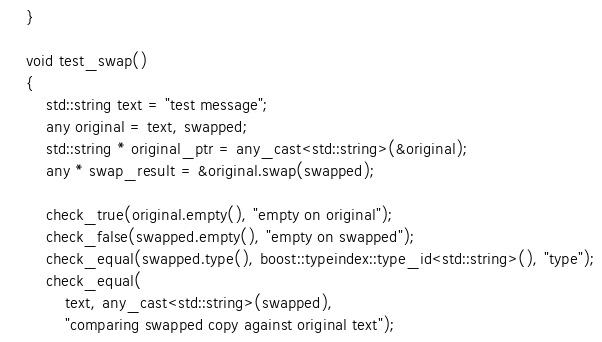<code> <loc_0><loc_0><loc_500><loc_500><_C++_>    }

    void test_swap()
    {
        std::string text = "test message";
        any original = text, swapped;
        std::string * original_ptr = any_cast<std::string>(&original);
        any * swap_result = &original.swap(swapped);

        check_true(original.empty(), "empty on original");
        check_false(swapped.empty(), "empty on swapped");
        check_equal(swapped.type(), boost::typeindex::type_id<std::string>(), "type");
        check_equal(
            text, any_cast<std::string>(swapped),
            "comparing swapped copy against original text");</code> 